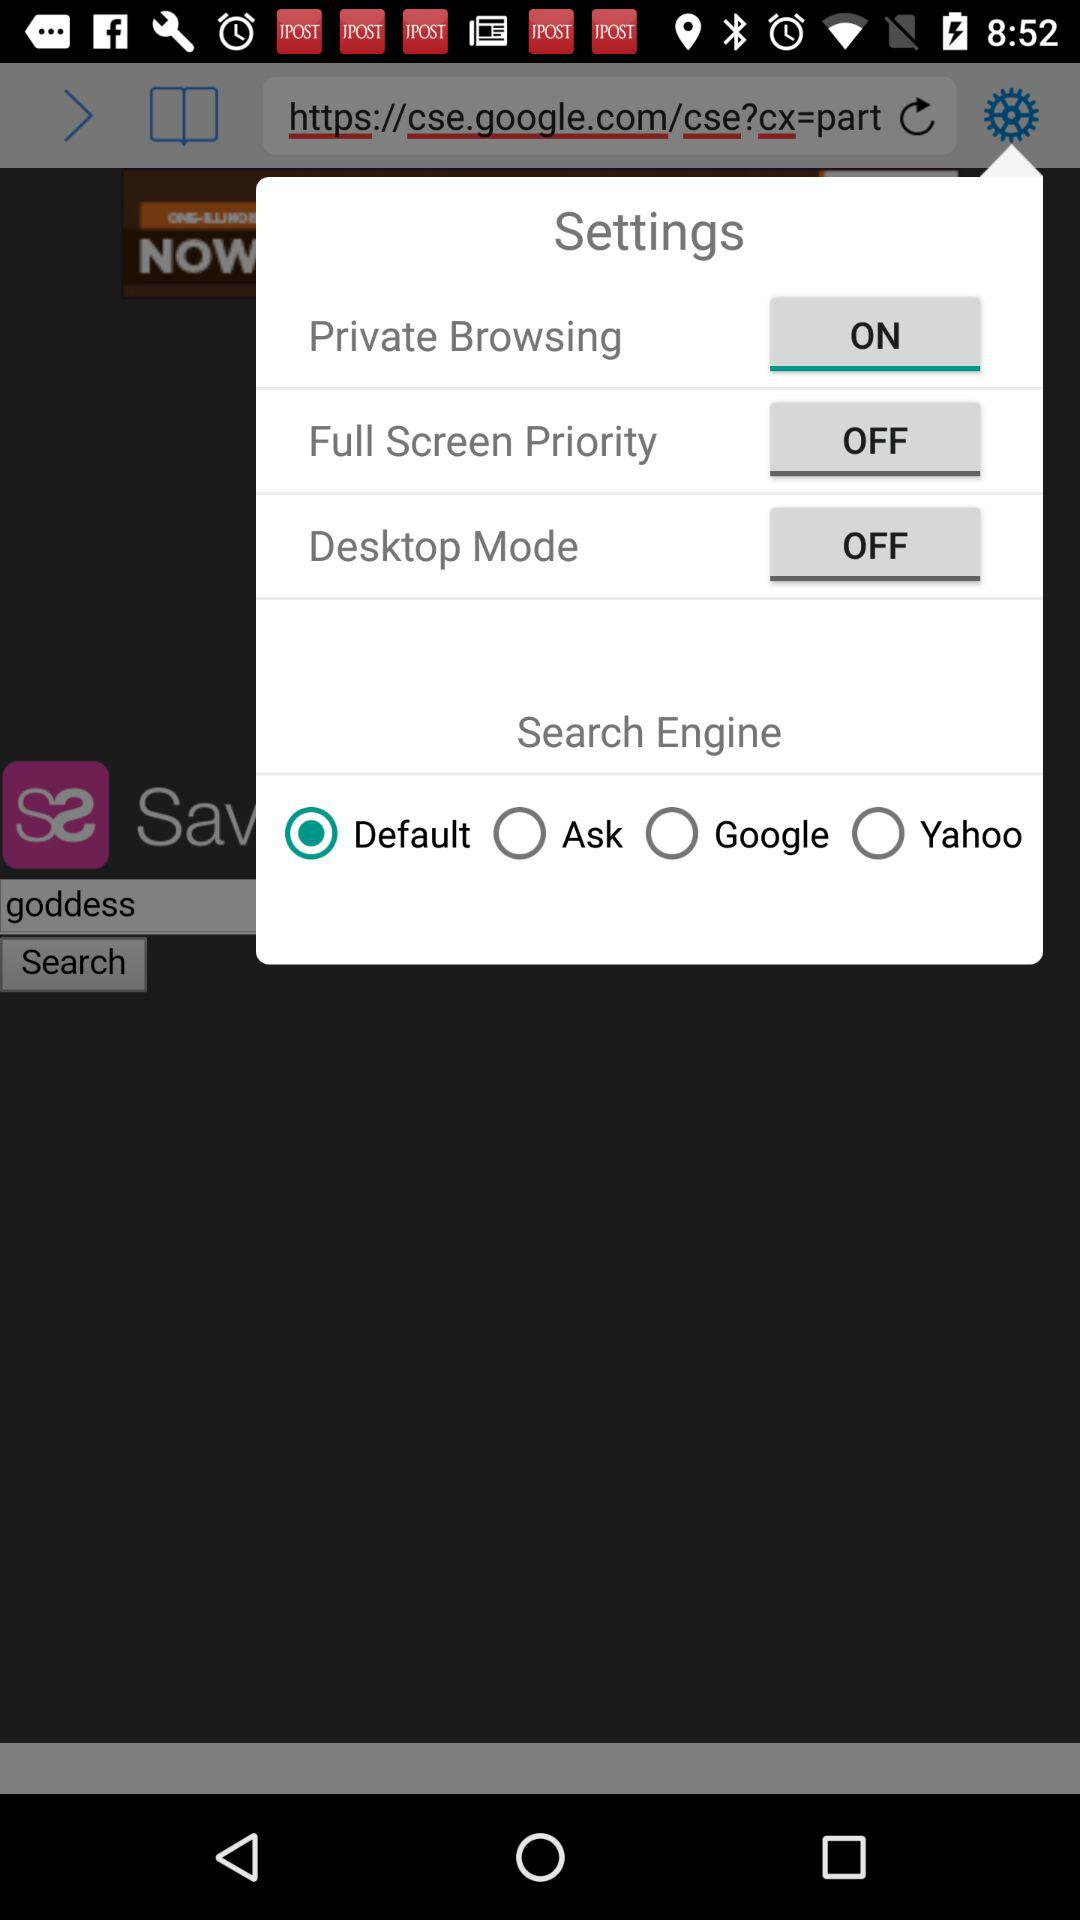How many search engines are available?
Answer the question using a single word or phrase. 4 